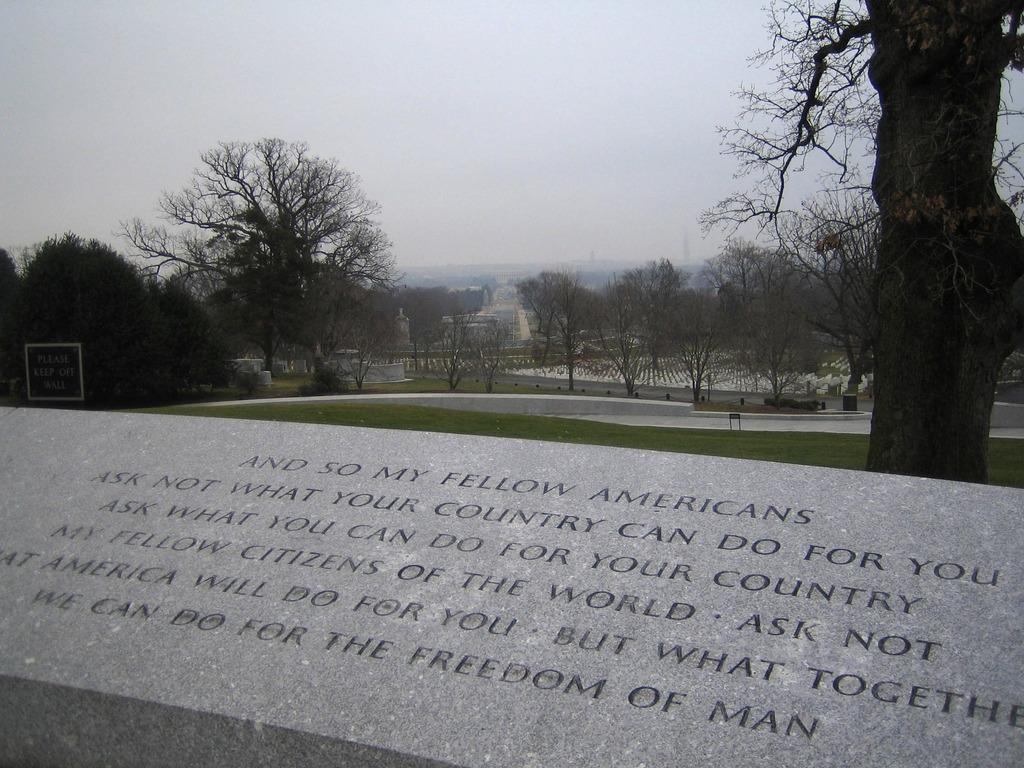What is the color of the surface in the image? The surface in the image is ash-colored. What is written on the surface? There are words written on the surface. What type of vegetation can be seen in the image? Grass is visible in the image, and there are also trees. What objects are present in the image? There is a board in the image. What can be seen in the background of the image? There are buildings, trees, and the sky visible in the background of the image. How many stars can be seen hanging from the board in the image? There are no stars present in the image, and therefore none can be seen hanging from the board. 